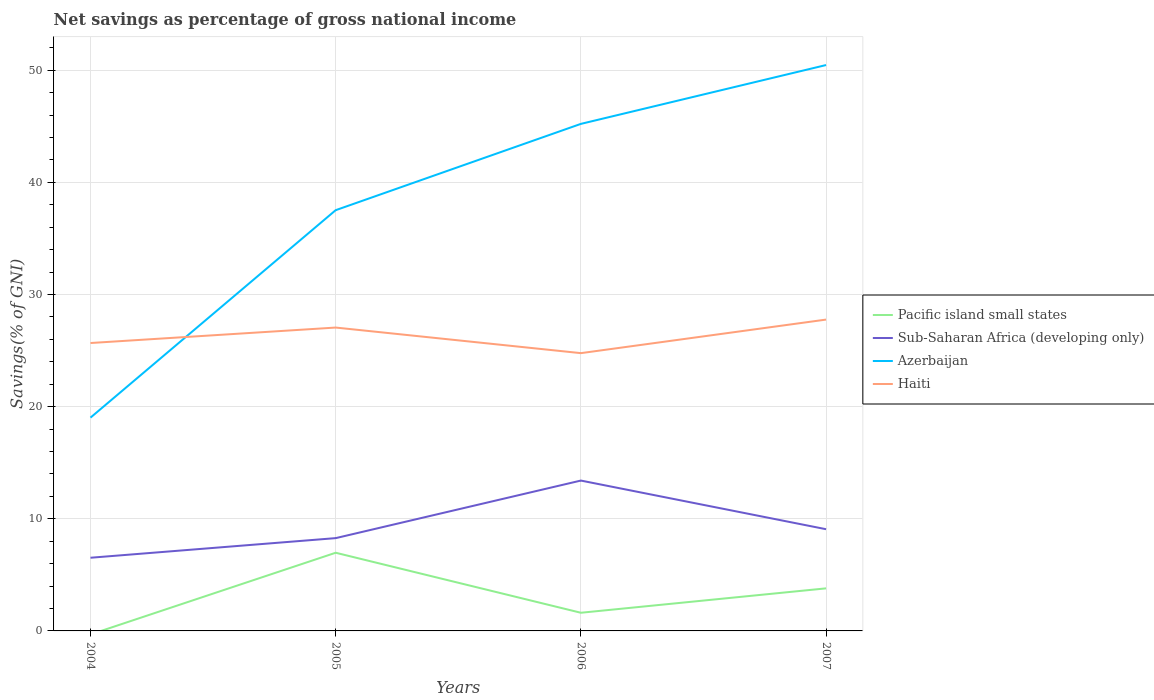Does the line corresponding to Sub-Saharan Africa (developing only) intersect with the line corresponding to Azerbaijan?
Give a very brief answer. No. Across all years, what is the maximum total savings in Sub-Saharan Africa (developing only)?
Offer a very short reply. 6.53. What is the total total savings in Sub-Saharan Africa (developing only) in the graph?
Provide a succinct answer. -5.13. What is the difference between the highest and the second highest total savings in Azerbaijan?
Ensure brevity in your answer.  31.45. Is the total savings in Pacific island small states strictly greater than the total savings in Sub-Saharan Africa (developing only) over the years?
Ensure brevity in your answer.  Yes. How many years are there in the graph?
Your response must be concise. 4. What is the difference between two consecutive major ticks on the Y-axis?
Provide a succinct answer. 10. Does the graph contain any zero values?
Your answer should be compact. Yes. How many legend labels are there?
Ensure brevity in your answer.  4. What is the title of the graph?
Your response must be concise. Net savings as percentage of gross national income. What is the label or title of the Y-axis?
Make the answer very short. Savings(% of GNI). What is the Savings(% of GNI) of Sub-Saharan Africa (developing only) in 2004?
Your answer should be compact. 6.53. What is the Savings(% of GNI) of Azerbaijan in 2004?
Your answer should be compact. 19.02. What is the Savings(% of GNI) in Haiti in 2004?
Give a very brief answer. 25.68. What is the Savings(% of GNI) in Pacific island small states in 2005?
Provide a succinct answer. 6.97. What is the Savings(% of GNI) in Sub-Saharan Africa (developing only) in 2005?
Your response must be concise. 8.28. What is the Savings(% of GNI) in Azerbaijan in 2005?
Offer a terse response. 37.52. What is the Savings(% of GNI) of Haiti in 2005?
Provide a short and direct response. 27.06. What is the Savings(% of GNI) in Pacific island small states in 2006?
Give a very brief answer. 1.62. What is the Savings(% of GNI) of Sub-Saharan Africa (developing only) in 2006?
Offer a very short reply. 13.41. What is the Savings(% of GNI) in Azerbaijan in 2006?
Keep it short and to the point. 45.22. What is the Savings(% of GNI) in Haiti in 2006?
Provide a short and direct response. 24.77. What is the Savings(% of GNI) in Pacific island small states in 2007?
Keep it short and to the point. 3.8. What is the Savings(% of GNI) in Sub-Saharan Africa (developing only) in 2007?
Give a very brief answer. 9.07. What is the Savings(% of GNI) in Azerbaijan in 2007?
Give a very brief answer. 50.47. What is the Savings(% of GNI) of Haiti in 2007?
Offer a terse response. 27.77. Across all years, what is the maximum Savings(% of GNI) in Pacific island small states?
Your answer should be compact. 6.97. Across all years, what is the maximum Savings(% of GNI) in Sub-Saharan Africa (developing only)?
Your answer should be compact. 13.41. Across all years, what is the maximum Savings(% of GNI) in Azerbaijan?
Your response must be concise. 50.47. Across all years, what is the maximum Savings(% of GNI) in Haiti?
Make the answer very short. 27.77. Across all years, what is the minimum Savings(% of GNI) in Sub-Saharan Africa (developing only)?
Your answer should be very brief. 6.53. Across all years, what is the minimum Savings(% of GNI) in Azerbaijan?
Keep it short and to the point. 19.02. Across all years, what is the minimum Savings(% of GNI) in Haiti?
Your answer should be compact. 24.77. What is the total Savings(% of GNI) of Pacific island small states in the graph?
Ensure brevity in your answer.  12.39. What is the total Savings(% of GNI) of Sub-Saharan Africa (developing only) in the graph?
Keep it short and to the point. 37.28. What is the total Savings(% of GNI) in Azerbaijan in the graph?
Ensure brevity in your answer.  152.24. What is the total Savings(% of GNI) in Haiti in the graph?
Make the answer very short. 105.27. What is the difference between the Savings(% of GNI) of Sub-Saharan Africa (developing only) in 2004 and that in 2005?
Give a very brief answer. -1.75. What is the difference between the Savings(% of GNI) of Azerbaijan in 2004 and that in 2005?
Your response must be concise. -18.5. What is the difference between the Savings(% of GNI) in Haiti in 2004 and that in 2005?
Your answer should be very brief. -1.38. What is the difference between the Savings(% of GNI) of Sub-Saharan Africa (developing only) in 2004 and that in 2006?
Provide a succinct answer. -6.88. What is the difference between the Savings(% of GNI) of Azerbaijan in 2004 and that in 2006?
Offer a terse response. -26.2. What is the difference between the Savings(% of GNI) of Haiti in 2004 and that in 2006?
Offer a very short reply. 0.9. What is the difference between the Savings(% of GNI) of Sub-Saharan Africa (developing only) in 2004 and that in 2007?
Keep it short and to the point. -2.54. What is the difference between the Savings(% of GNI) of Azerbaijan in 2004 and that in 2007?
Your answer should be very brief. -31.45. What is the difference between the Savings(% of GNI) in Haiti in 2004 and that in 2007?
Ensure brevity in your answer.  -2.09. What is the difference between the Savings(% of GNI) of Pacific island small states in 2005 and that in 2006?
Your answer should be compact. 5.35. What is the difference between the Savings(% of GNI) in Sub-Saharan Africa (developing only) in 2005 and that in 2006?
Make the answer very short. -5.13. What is the difference between the Savings(% of GNI) of Azerbaijan in 2005 and that in 2006?
Provide a short and direct response. -7.7. What is the difference between the Savings(% of GNI) of Haiti in 2005 and that in 2006?
Provide a succinct answer. 2.28. What is the difference between the Savings(% of GNI) of Pacific island small states in 2005 and that in 2007?
Your answer should be compact. 3.18. What is the difference between the Savings(% of GNI) in Sub-Saharan Africa (developing only) in 2005 and that in 2007?
Provide a short and direct response. -0.8. What is the difference between the Savings(% of GNI) of Azerbaijan in 2005 and that in 2007?
Your response must be concise. -12.94. What is the difference between the Savings(% of GNI) in Haiti in 2005 and that in 2007?
Keep it short and to the point. -0.71. What is the difference between the Savings(% of GNI) of Pacific island small states in 2006 and that in 2007?
Your answer should be very brief. -2.18. What is the difference between the Savings(% of GNI) of Sub-Saharan Africa (developing only) in 2006 and that in 2007?
Your answer should be compact. 4.34. What is the difference between the Savings(% of GNI) of Azerbaijan in 2006 and that in 2007?
Provide a short and direct response. -5.25. What is the difference between the Savings(% of GNI) in Haiti in 2006 and that in 2007?
Offer a terse response. -2.99. What is the difference between the Savings(% of GNI) in Sub-Saharan Africa (developing only) in 2004 and the Savings(% of GNI) in Azerbaijan in 2005?
Your answer should be compact. -31. What is the difference between the Savings(% of GNI) of Sub-Saharan Africa (developing only) in 2004 and the Savings(% of GNI) of Haiti in 2005?
Make the answer very short. -20.53. What is the difference between the Savings(% of GNI) of Azerbaijan in 2004 and the Savings(% of GNI) of Haiti in 2005?
Offer a terse response. -8.03. What is the difference between the Savings(% of GNI) of Sub-Saharan Africa (developing only) in 2004 and the Savings(% of GNI) of Azerbaijan in 2006?
Provide a succinct answer. -38.69. What is the difference between the Savings(% of GNI) of Sub-Saharan Africa (developing only) in 2004 and the Savings(% of GNI) of Haiti in 2006?
Offer a very short reply. -18.25. What is the difference between the Savings(% of GNI) of Azerbaijan in 2004 and the Savings(% of GNI) of Haiti in 2006?
Your answer should be compact. -5.75. What is the difference between the Savings(% of GNI) of Sub-Saharan Africa (developing only) in 2004 and the Savings(% of GNI) of Azerbaijan in 2007?
Give a very brief answer. -43.94. What is the difference between the Savings(% of GNI) in Sub-Saharan Africa (developing only) in 2004 and the Savings(% of GNI) in Haiti in 2007?
Your answer should be compact. -21.24. What is the difference between the Savings(% of GNI) of Azerbaijan in 2004 and the Savings(% of GNI) of Haiti in 2007?
Ensure brevity in your answer.  -8.74. What is the difference between the Savings(% of GNI) of Pacific island small states in 2005 and the Savings(% of GNI) of Sub-Saharan Africa (developing only) in 2006?
Give a very brief answer. -6.44. What is the difference between the Savings(% of GNI) of Pacific island small states in 2005 and the Savings(% of GNI) of Azerbaijan in 2006?
Your answer should be compact. -38.25. What is the difference between the Savings(% of GNI) in Pacific island small states in 2005 and the Savings(% of GNI) in Haiti in 2006?
Make the answer very short. -17.8. What is the difference between the Savings(% of GNI) in Sub-Saharan Africa (developing only) in 2005 and the Savings(% of GNI) in Azerbaijan in 2006?
Your response must be concise. -36.95. What is the difference between the Savings(% of GNI) in Sub-Saharan Africa (developing only) in 2005 and the Savings(% of GNI) in Haiti in 2006?
Provide a short and direct response. -16.5. What is the difference between the Savings(% of GNI) in Azerbaijan in 2005 and the Savings(% of GNI) in Haiti in 2006?
Your response must be concise. 12.75. What is the difference between the Savings(% of GNI) in Pacific island small states in 2005 and the Savings(% of GNI) in Sub-Saharan Africa (developing only) in 2007?
Keep it short and to the point. -2.1. What is the difference between the Savings(% of GNI) in Pacific island small states in 2005 and the Savings(% of GNI) in Azerbaijan in 2007?
Ensure brevity in your answer.  -43.5. What is the difference between the Savings(% of GNI) in Pacific island small states in 2005 and the Savings(% of GNI) in Haiti in 2007?
Give a very brief answer. -20.79. What is the difference between the Savings(% of GNI) of Sub-Saharan Africa (developing only) in 2005 and the Savings(% of GNI) of Azerbaijan in 2007?
Give a very brief answer. -42.19. What is the difference between the Savings(% of GNI) in Sub-Saharan Africa (developing only) in 2005 and the Savings(% of GNI) in Haiti in 2007?
Your answer should be very brief. -19.49. What is the difference between the Savings(% of GNI) of Azerbaijan in 2005 and the Savings(% of GNI) of Haiti in 2007?
Give a very brief answer. 9.76. What is the difference between the Savings(% of GNI) in Pacific island small states in 2006 and the Savings(% of GNI) in Sub-Saharan Africa (developing only) in 2007?
Your response must be concise. -7.45. What is the difference between the Savings(% of GNI) in Pacific island small states in 2006 and the Savings(% of GNI) in Azerbaijan in 2007?
Make the answer very short. -48.85. What is the difference between the Savings(% of GNI) of Pacific island small states in 2006 and the Savings(% of GNI) of Haiti in 2007?
Offer a terse response. -26.15. What is the difference between the Savings(% of GNI) in Sub-Saharan Africa (developing only) in 2006 and the Savings(% of GNI) in Azerbaijan in 2007?
Offer a terse response. -37.06. What is the difference between the Savings(% of GNI) of Sub-Saharan Africa (developing only) in 2006 and the Savings(% of GNI) of Haiti in 2007?
Offer a very short reply. -14.36. What is the difference between the Savings(% of GNI) in Azerbaijan in 2006 and the Savings(% of GNI) in Haiti in 2007?
Make the answer very short. 17.45. What is the average Savings(% of GNI) of Pacific island small states per year?
Offer a terse response. 3.1. What is the average Savings(% of GNI) of Sub-Saharan Africa (developing only) per year?
Make the answer very short. 9.32. What is the average Savings(% of GNI) in Azerbaijan per year?
Your answer should be compact. 38.06. What is the average Savings(% of GNI) of Haiti per year?
Your response must be concise. 26.32. In the year 2004, what is the difference between the Savings(% of GNI) of Sub-Saharan Africa (developing only) and Savings(% of GNI) of Azerbaijan?
Your response must be concise. -12.5. In the year 2004, what is the difference between the Savings(% of GNI) in Sub-Saharan Africa (developing only) and Savings(% of GNI) in Haiti?
Provide a succinct answer. -19.15. In the year 2004, what is the difference between the Savings(% of GNI) of Azerbaijan and Savings(% of GNI) of Haiti?
Ensure brevity in your answer.  -6.65. In the year 2005, what is the difference between the Savings(% of GNI) of Pacific island small states and Savings(% of GNI) of Sub-Saharan Africa (developing only)?
Give a very brief answer. -1.3. In the year 2005, what is the difference between the Savings(% of GNI) of Pacific island small states and Savings(% of GNI) of Azerbaijan?
Give a very brief answer. -30.55. In the year 2005, what is the difference between the Savings(% of GNI) of Pacific island small states and Savings(% of GNI) of Haiti?
Make the answer very short. -20.08. In the year 2005, what is the difference between the Savings(% of GNI) in Sub-Saharan Africa (developing only) and Savings(% of GNI) in Azerbaijan?
Your answer should be compact. -29.25. In the year 2005, what is the difference between the Savings(% of GNI) in Sub-Saharan Africa (developing only) and Savings(% of GNI) in Haiti?
Your answer should be very brief. -18.78. In the year 2005, what is the difference between the Savings(% of GNI) of Azerbaijan and Savings(% of GNI) of Haiti?
Offer a very short reply. 10.47. In the year 2006, what is the difference between the Savings(% of GNI) in Pacific island small states and Savings(% of GNI) in Sub-Saharan Africa (developing only)?
Give a very brief answer. -11.79. In the year 2006, what is the difference between the Savings(% of GNI) in Pacific island small states and Savings(% of GNI) in Azerbaijan?
Keep it short and to the point. -43.6. In the year 2006, what is the difference between the Savings(% of GNI) in Pacific island small states and Savings(% of GNI) in Haiti?
Your response must be concise. -23.15. In the year 2006, what is the difference between the Savings(% of GNI) of Sub-Saharan Africa (developing only) and Savings(% of GNI) of Azerbaijan?
Ensure brevity in your answer.  -31.81. In the year 2006, what is the difference between the Savings(% of GNI) of Sub-Saharan Africa (developing only) and Savings(% of GNI) of Haiti?
Make the answer very short. -11.36. In the year 2006, what is the difference between the Savings(% of GNI) of Azerbaijan and Savings(% of GNI) of Haiti?
Give a very brief answer. 20.45. In the year 2007, what is the difference between the Savings(% of GNI) in Pacific island small states and Savings(% of GNI) in Sub-Saharan Africa (developing only)?
Offer a terse response. -5.28. In the year 2007, what is the difference between the Savings(% of GNI) in Pacific island small states and Savings(% of GNI) in Azerbaijan?
Offer a terse response. -46.67. In the year 2007, what is the difference between the Savings(% of GNI) of Pacific island small states and Savings(% of GNI) of Haiti?
Make the answer very short. -23.97. In the year 2007, what is the difference between the Savings(% of GNI) in Sub-Saharan Africa (developing only) and Savings(% of GNI) in Azerbaijan?
Your answer should be compact. -41.4. In the year 2007, what is the difference between the Savings(% of GNI) of Sub-Saharan Africa (developing only) and Savings(% of GNI) of Haiti?
Offer a very short reply. -18.7. In the year 2007, what is the difference between the Savings(% of GNI) of Azerbaijan and Savings(% of GNI) of Haiti?
Make the answer very short. 22.7. What is the ratio of the Savings(% of GNI) in Sub-Saharan Africa (developing only) in 2004 to that in 2005?
Offer a terse response. 0.79. What is the ratio of the Savings(% of GNI) of Azerbaijan in 2004 to that in 2005?
Offer a terse response. 0.51. What is the ratio of the Savings(% of GNI) of Haiti in 2004 to that in 2005?
Ensure brevity in your answer.  0.95. What is the ratio of the Savings(% of GNI) in Sub-Saharan Africa (developing only) in 2004 to that in 2006?
Your answer should be very brief. 0.49. What is the ratio of the Savings(% of GNI) of Azerbaijan in 2004 to that in 2006?
Your answer should be compact. 0.42. What is the ratio of the Savings(% of GNI) of Haiti in 2004 to that in 2006?
Provide a succinct answer. 1.04. What is the ratio of the Savings(% of GNI) of Sub-Saharan Africa (developing only) in 2004 to that in 2007?
Keep it short and to the point. 0.72. What is the ratio of the Savings(% of GNI) of Azerbaijan in 2004 to that in 2007?
Offer a terse response. 0.38. What is the ratio of the Savings(% of GNI) of Haiti in 2004 to that in 2007?
Offer a terse response. 0.92. What is the ratio of the Savings(% of GNI) in Pacific island small states in 2005 to that in 2006?
Your answer should be very brief. 4.3. What is the ratio of the Savings(% of GNI) of Sub-Saharan Africa (developing only) in 2005 to that in 2006?
Make the answer very short. 0.62. What is the ratio of the Savings(% of GNI) in Azerbaijan in 2005 to that in 2006?
Your answer should be very brief. 0.83. What is the ratio of the Savings(% of GNI) in Haiti in 2005 to that in 2006?
Make the answer very short. 1.09. What is the ratio of the Savings(% of GNI) of Pacific island small states in 2005 to that in 2007?
Make the answer very short. 1.84. What is the ratio of the Savings(% of GNI) of Sub-Saharan Africa (developing only) in 2005 to that in 2007?
Offer a terse response. 0.91. What is the ratio of the Savings(% of GNI) in Azerbaijan in 2005 to that in 2007?
Ensure brevity in your answer.  0.74. What is the ratio of the Savings(% of GNI) in Haiti in 2005 to that in 2007?
Give a very brief answer. 0.97. What is the ratio of the Savings(% of GNI) in Pacific island small states in 2006 to that in 2007?
Offer a very short reply. 0.43. What is the ratio of the Savings(% of GNI) of Sub-Saharan Africa (developing only) in 2006 to that in 2007?
Your answer should be compact. 1.48. What is the ratio of the Savings(% of GNI) of Azerbaijan in 2006 to that in 2007?
Offer a terse response. 0.9. What is the ratio of the Savings(% of GNI) of Haiti in 2006 to that in 2007?
Your response must be concise. 0.89. What is the difference between the highest and the second highest Savings(% of GNI) of Pacific island small states?
Your response must be concise. 3.18. What is the difference between the highest and the second highest Savings(% of GNI) of Sub-Saharan Africa (developing only)?
Your response must be concise. 4.34. What is the difference between the highest and the second highest Savings(% of GNI) of Azerbaijan?
Your answer should be very brief. 5.25. What is the difference between the highest and the second highest Savings(% of GNI) of Haiti?
Make the answer very short. 0.71. What is the difference between the highest and the lowest Savings(% of GNI) of Pacific island small states?
Offer a terse response. 6.97. What is the difference between the highest and the lowest Savings(% of GNI) in Sub-Saharan Africa (developing only)?
Your answer should be very brief. 6.88. What is the difference between the highest and the lowest Savings(% of GNI) in Azerbaijan?
Provide a short and direct response. 31.45. What is the difference between the highest and the lowest Savings(% of GNI) of Haiti?
Ensure brevity in your answer.  2.99. 